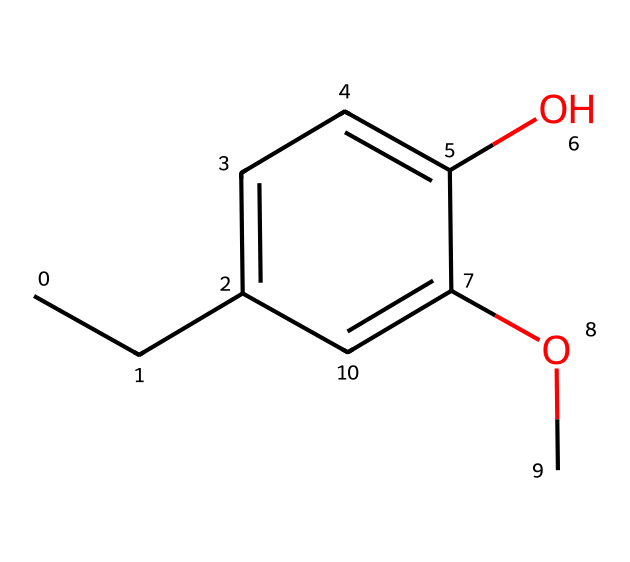What is the molecular formula of eugenol? To find the molecular formula, count the number of each type of atom in the SMILES: there are 10 carbon (C) atoms, 12 hydrogen (H) atoms, and 2 oxygen (O) atoms, giving the formula C10H12O2.
Answer: C10H12O2 How many rings are present in the structure of eugenol? Looking at the chemical structure derived from the SMILES, there is one aromatic ring present, which is a distinct feature of eugenol.
Answer: 1 What functional groups are present in eugenol? The structure shows a hydroxyl (OH) group and a methoxy (OCH3) group, both of which are characteristic of eugenol, differentiating it from simple hydrocarbons.
Answer: hydroxyl and methoxy Is eugenol a polar or non-polar molecule? The presence of the hydroxyl group indicates a level of polarity due to its ability to form hydrogen bonds, while the aromatic and alkyl parts contribute to a degree of non-polar character, making it a polar molecule overall.
Answer: polar What is a primary use of eugenol in various products? Eugenol is commonly used for its spicy and aromatic scent in liniments and massage oils, as it offers calming and soothing properties associated with these applications.
Answer: liniments and massage oils What characteristic scent does eugenol provide? The structure includes aromatic components that indicate it has a spicy, clove-like scent, which is well-known and widely recognized in various flavors and fragrances.
Answer: spicy, clove-like scent 